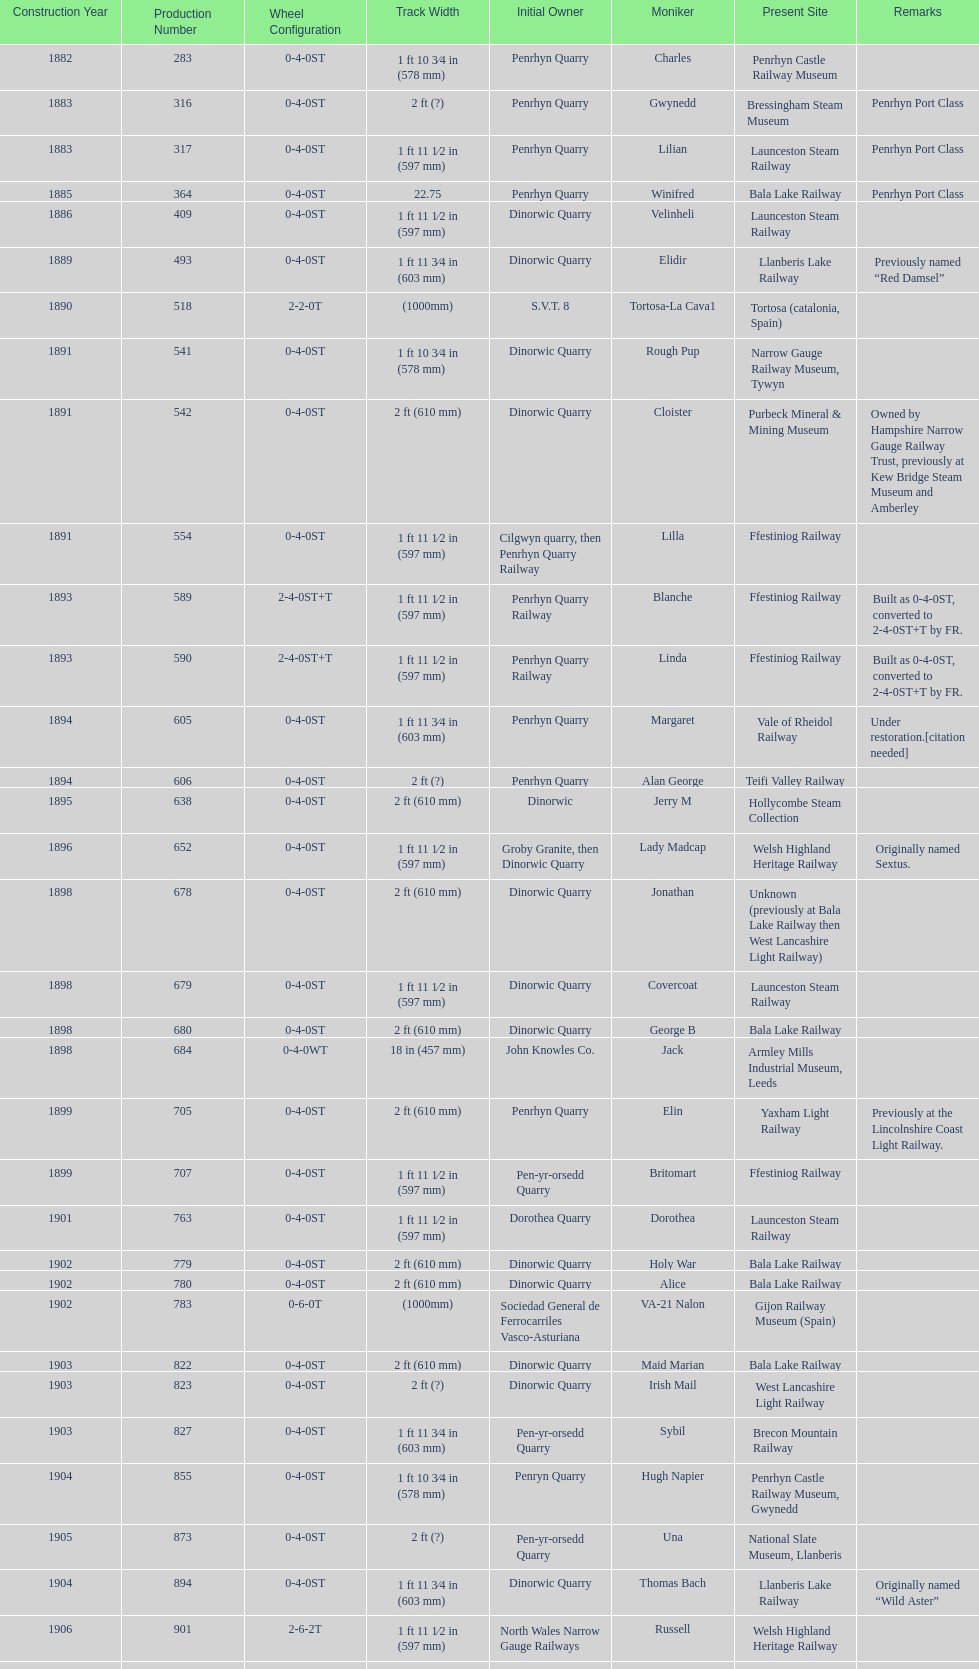Aside from 316, what was the other works number used in 1883? 317. 